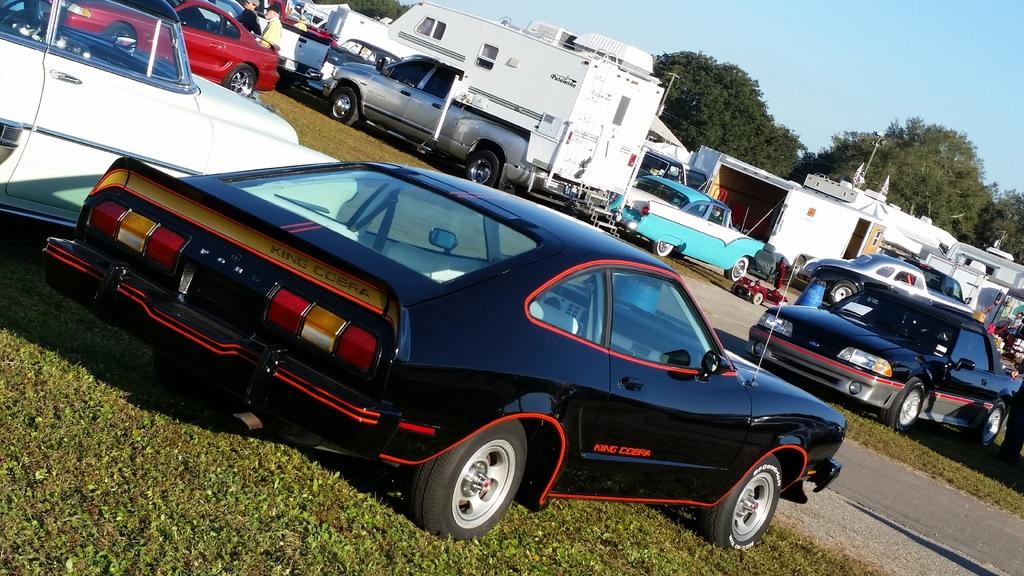What type of terrain is visible in the image? There is a grassy land in the image. What color is the sky in the image? The sky is blue in the image. What can be seen running through the grassy land? There is a road in the image. What type of objects can be seen on the road? There are vehicles in the image. How many people are present in the image? There are two persons in the image. What type of station can be seen in the image? There is no station present in the image. What action are the two persons performing in the image? The image does not show any specific action being performed by the two persons. 